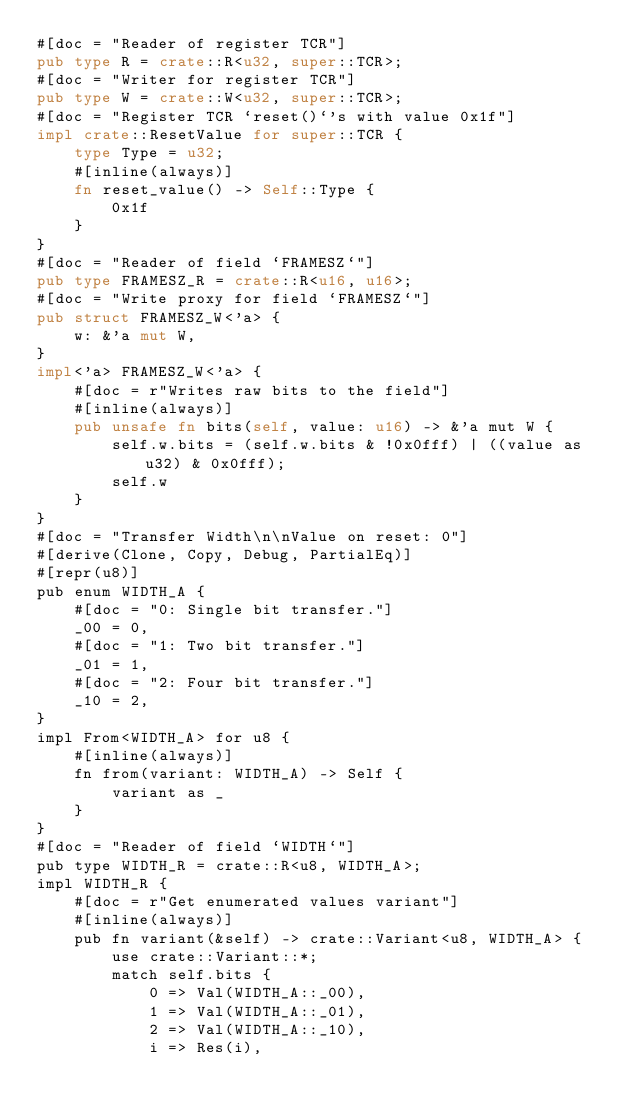<code> <loc_0><loc_0><loc_500><loc_500><_Rust_>#[doc = "Reader of register TCR"]
pub type R = crate::R<u32, super::TCR>;
#[doc = "Writer for register TCR"]
pub type W = crate::W<u32, super::TCR>;
#[doc = "Register TCR `reset()`'s with value 0x1f"]
impl crate::ResetValue for super::TCR {
    type Type = u32;
    #[inline(always)]
    fn reset_value() -> Self::Type {
        0x1f
    }
}
#[doc = "Reader of field `FRAMESZ`"]
pub type FRAMESZ_R = crate::R<u16, u16>;
#[doc = "Write proxy for field `FRAMESZ`"]
pub struct FRAMESZ_W<'a> {
    w: &'a mut W,
}
impl<'a> FRAMESZ_W<'a> {
    #[doc = r"Writes raw bits to the field"]
    #[inline(always)]
    pub unsafe fn bits(self, value: u16) -> &'a mut W {
        self.w.bits = (self.w.bits & !0x0fff) | ((value as u32) & 0x0fff);
        self.w
    }
}
#[doc = "Transfer Width\n\nValue on reset: 0"]
#[derive(Clone, Copy, Debug, PartialEq)]
#[repr(u8)]
pub enum WIDTH_A {
    #[doc = "0: Single bit transfer."]
    _00 = 0,
    #[doc = "1: Two bit transfer."]
    _01 = 1,
    #[doc = "2: Four bit transfer."]
    _10 = 2,
}
impl From<WIDTH_A> for u8 {
    #[inline(always)]
    fn from(variant: WIDTH_A) -> Self {
        variant as _
    }
}
#[doc = "Reader of field `WIDTH`"]
pub type WIDTH_R = crate::R<u8, WIDTH_A>;
impl WIDTH_R {
    #[doc = r"Get enumerated values variant"]
    #[inline(always)]
    pub fn variant(&self) -> crate::Variant<u8, WIDTH_A> {
        use crate::Variant::*;
        match self.bits {
            0 => Val(WIDTH_A::_00),
            1 => Val(WIDTH_A::_01),
            2 => Val(WIDTH_A::_10),
            i => Res(i),</code> 